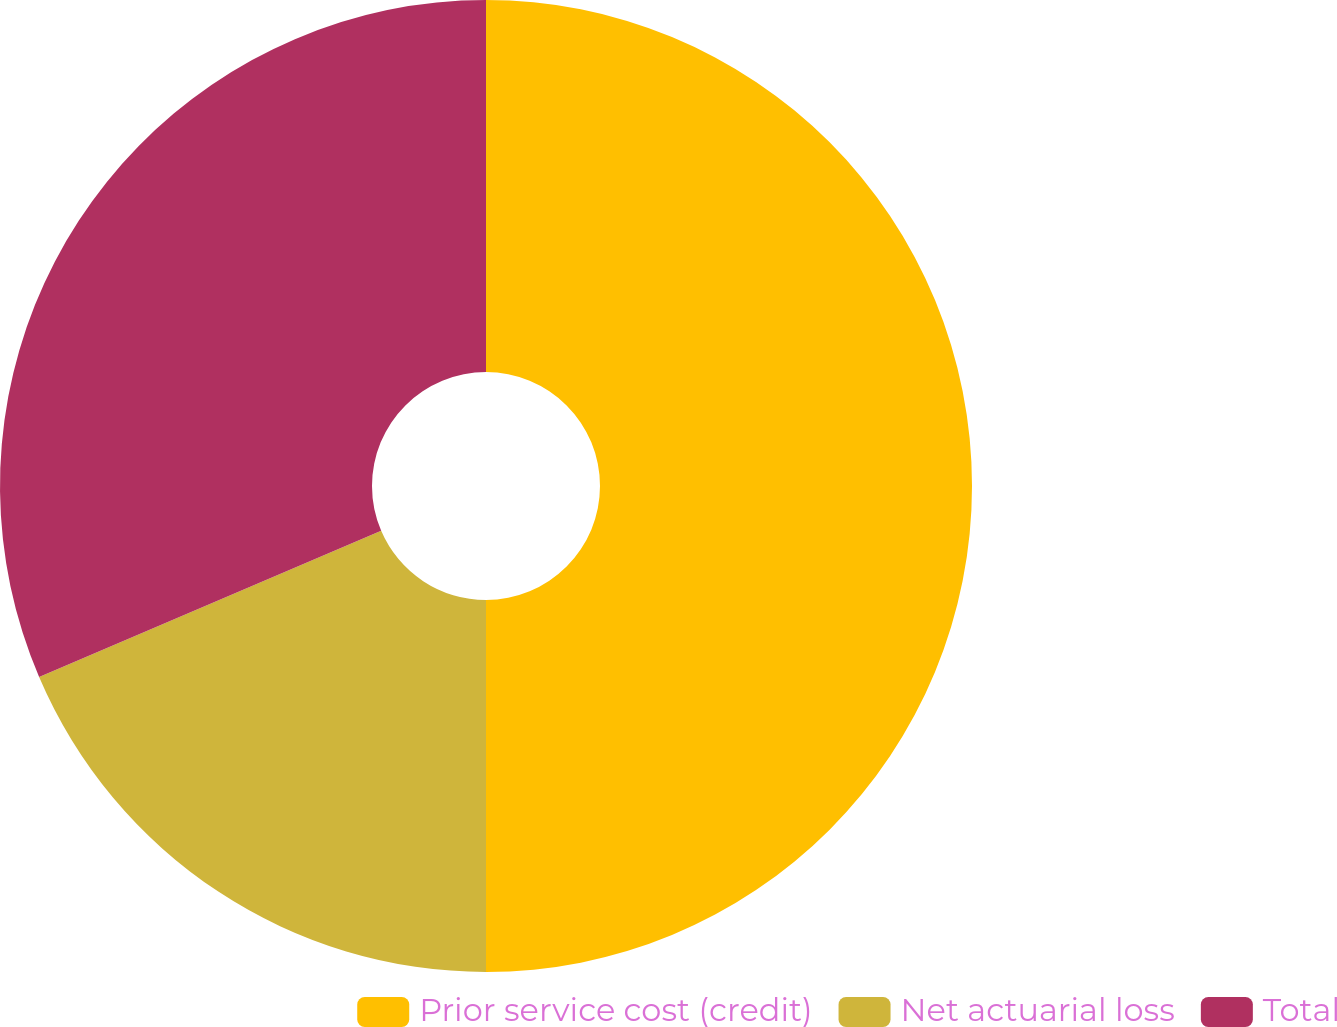<chart> <loc_0><loc_0><loc_500><loc_500><pie_chart><fcel>Prior service cost (credit)<fcel>Net actuarial loss<fcel>Total<nl><fcel>50.0%<fcel>18.57%<fcel>31.43%<nl></chart> 